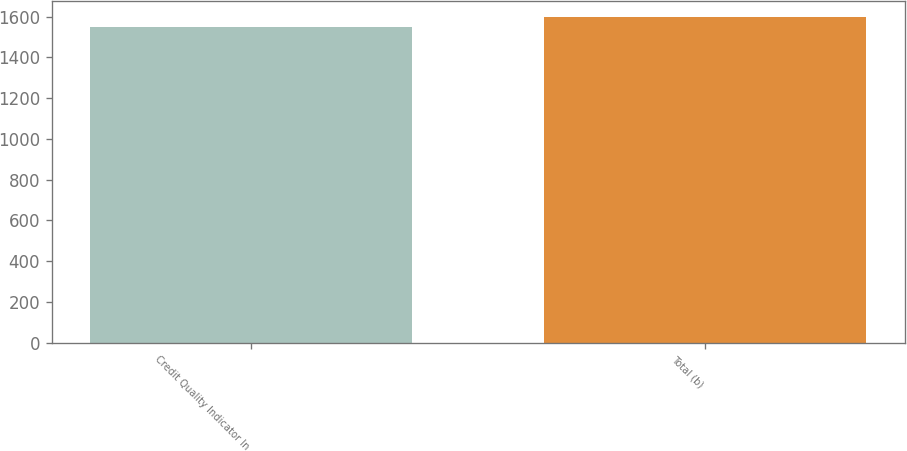Convert chart. <chart><loc_0><loc_0><loc_500><loc_500><bar_chart><fcel>Credit Quality Indicator In<fcel>Total (b)<nl><fcel>1549<fcel>1599<nl></chart> 